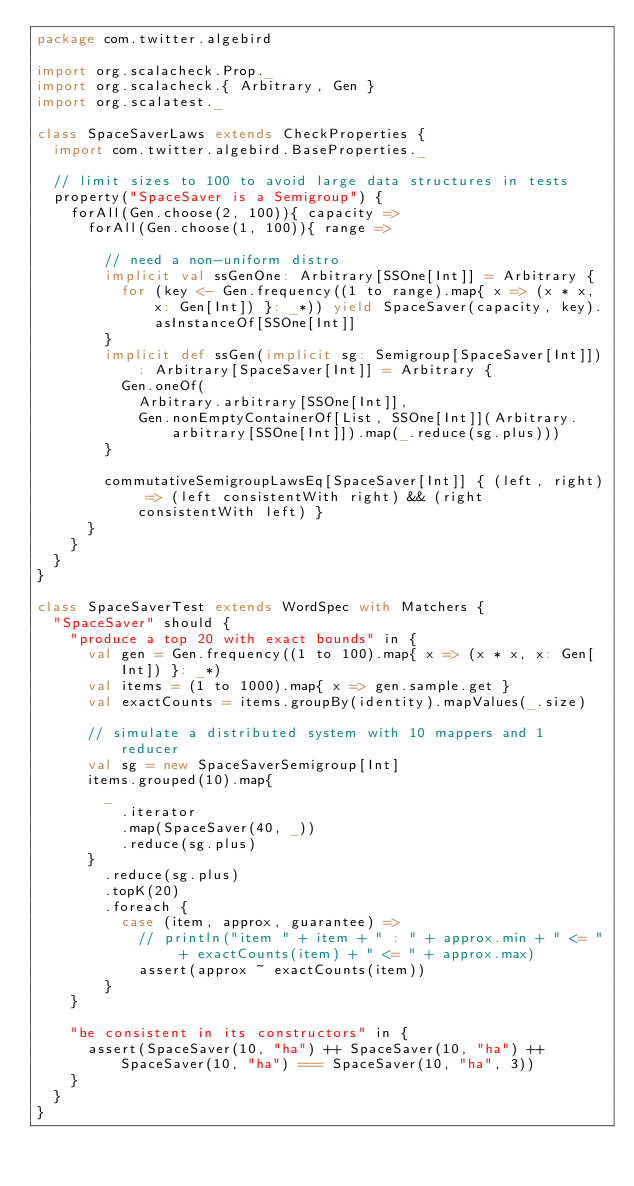<code> <loc_0><loc_0><loc_500><loc_500><_Scala_>package com.twitter.algebird

import org.scalacheck.Prop._
import org.scalacheck.{ Arbitrary, Gen }
import org.scalatest._

class SpaceSaverLaws extends CheckProperties {
  import com.twitter.algebird.BaseProperties._

  // limit sizes to 100 to avoid large data structures in tests
  property("SpaceSaver is a Semigroup") {
    forAll(Gen.choose(2, 100)){ capacity =>
      forAll(Gen.choose(1, 100)){ range =>

        // need a non-uniform distro
        implicit val ssGenOne: Arbitrary[SSOne[Int]] = Arbitrary {
          for (key <- Gen.frequency((1 to range).map{ x => (x * x, x: Gen[Int]) }: _*)) yield SpaceSaver(capacity, key).asInstanceOf[SSOne[Int]]
        }
        implicit def ssGen(implicit sg: Semigroup[SpaceSaver[Int]]): Arbitrary[SpaceSaver[Int]] = Arbitrary {
          Gen.oneOf(
            Arbitrary.arbitrary[SSOne[Int]],
            Gen.nonEmptyContainerOf[List, SSOne[Int]](Arbitrary.arbitrary[SSOne[Int]]).map(_.reduce(sg.plus)))
        }

        commutativeSemigroupLawsEq[SpaceSaver[Int]] { (left, right) => (left consistentWith right) && (right consistentWith left) }
      }
    }
  }
}

class SpaceSaverTest extends WordSpec with Matchers {
  "SpaceSaver" should {
    "produce a top 20 with exact bounds" in {
      val gen = Gen.frequency((1 to 100).map{ x => (x * x, x: Gen[Int]) }: _*)
      val items = (1 to 1000).map{ x => gen.sample.get }
      val exactCounts = items.groupBy(identity).mapValues(_.size)

      // simulate a distributed system with 10 mappers and 1 reducer
      val sg = new SpaceSaverSemigroup[Int]
      items.grouped(10).map{
        _
          .iterator
          .map(SpaceSaver(40, _))
          .reduce(sg.plus)
      }
        .reduce(sg.plus)
        .topK(20)
        .foreach {
          case (item, approx, guarantee) =>
            // println("item " + item + " : " + approx.min + " <= " + exactCounts(item) + " <= " + approx.max)
            assert(approx ~ exactCounts(item))
        }
    }

    "be consistent in its constructors" in {
      assert(SpaceSaver(10, "ha") ++ SpaceSaver(10, "ha") ++ SpaceSaver(10, "ha") === SpaceSaver(10, "ha", 3))
    }
  }
}
</code> 